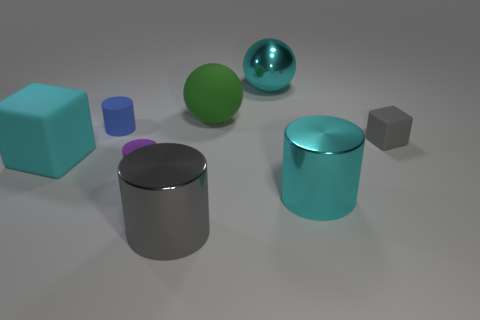Add 1 large cyan metallic cylinders. How many objects exist? 9 Subtract all balls. How many objects are left? 6 Subtract all big cyan cylinders. Subtract all small matte cylinders. How many objects are left? 5 Add 7 small gray rubber cubes. How many small gray rubber cubes are left? 8 Add 2 tiny rubber cylinders. How many tiny rubber cylinders exist? 4 Subtract 0 red balls. How many objects are left? 8 